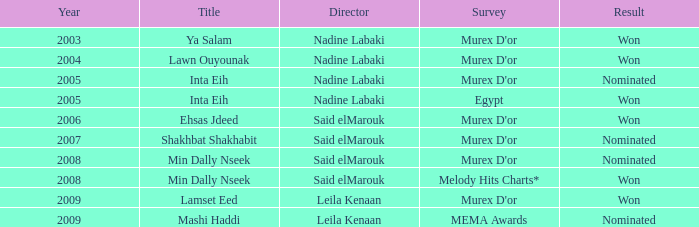What is the consequence for director said elmarouk before 2008? Won, Nominated. 